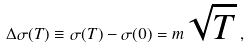Convert formula to latex. <formula><loc_0><loc_0><loc_500><loc_500>\Delta \sigma ( T ) \equiv \sigma ( T ) - \sigma ( 0 ) = m \sqrt { T } \, ,</formula> 